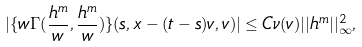Convert formula to latex. <formula><loc_0><loc_0><loc_500><loc_500>| \{ w \Gamma ( \frac { h ^ { m } } { w } , \frac { h ^ { m } } { w } ) \} ( s , x - ( t - s ) v , v ) | \leq C \nu ( v ) | | h ^ { m } | | _ { \infty } ^ { 2 } ,</formula> 